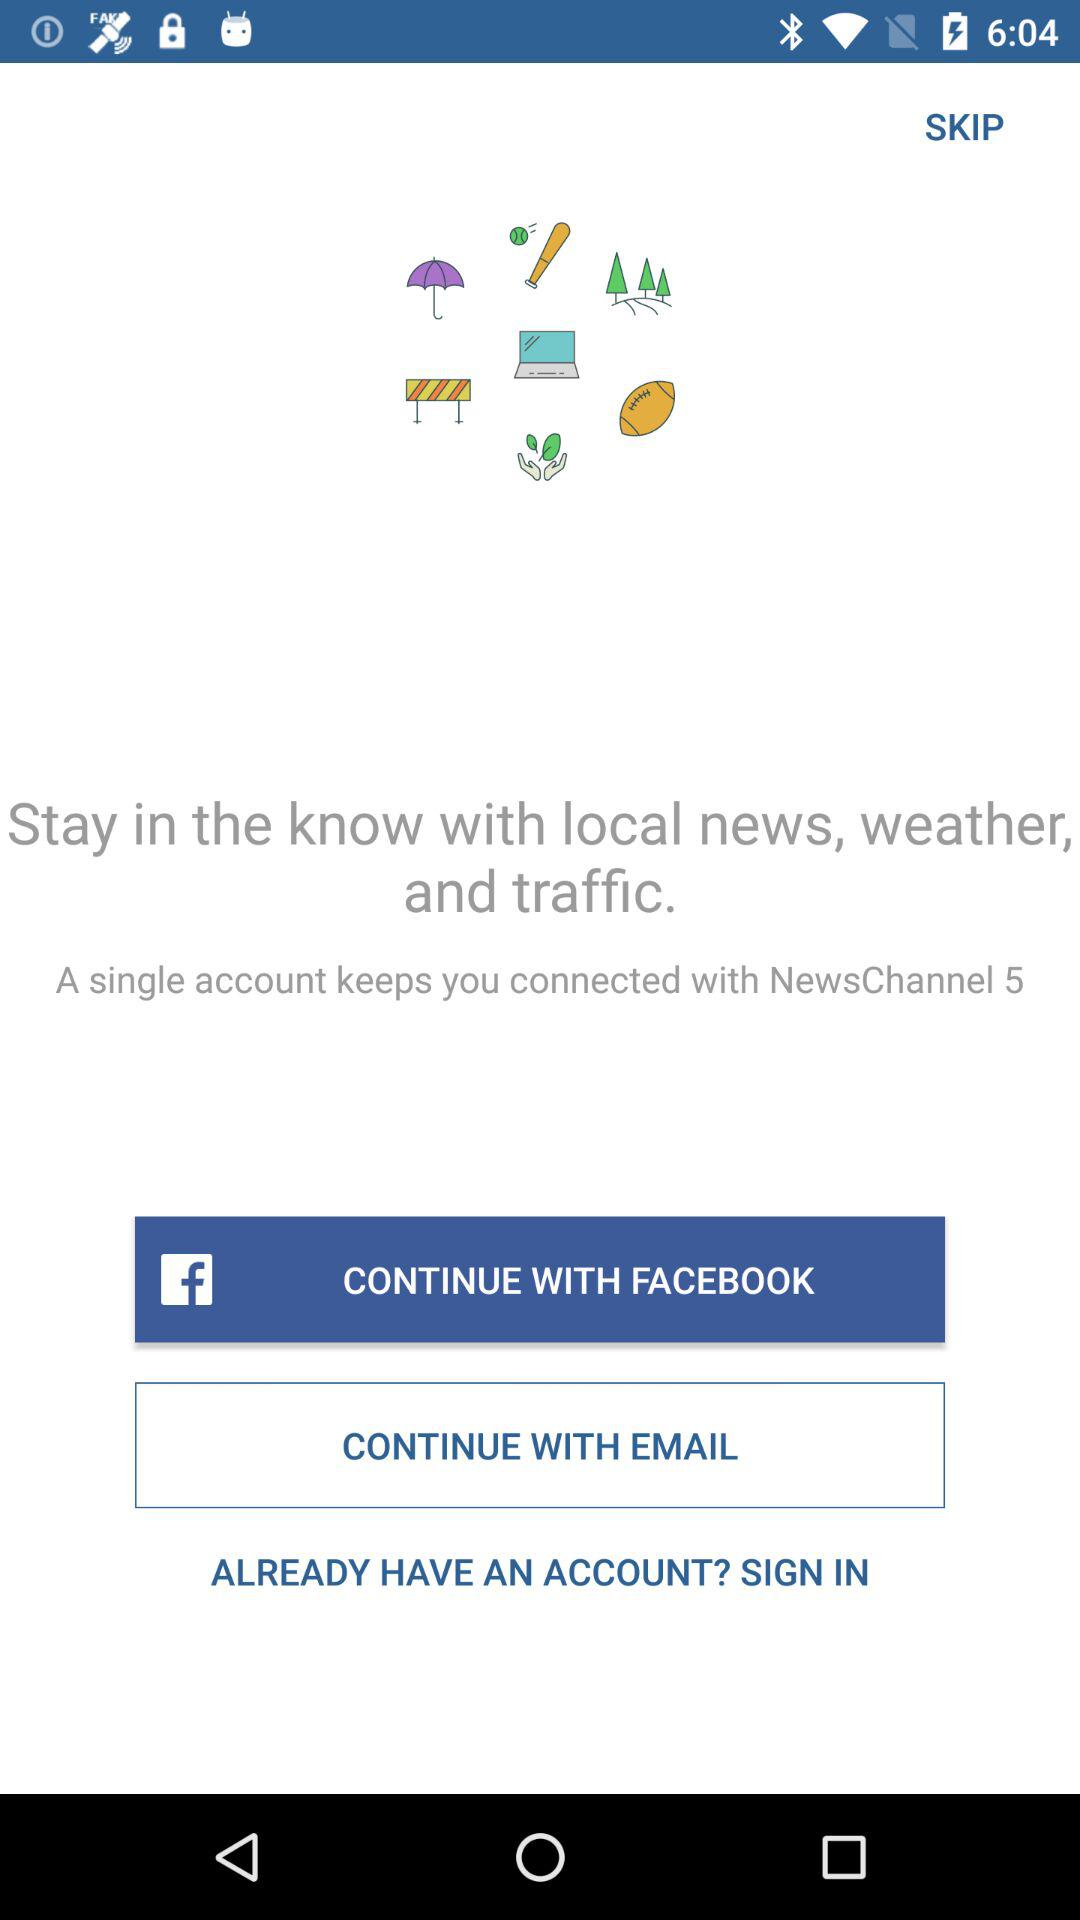What applications can be used to log in to a profile? The application that can be used to log in is "FACEBOOK". 